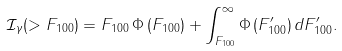<formula> <loc_0><loc_0><loc_500><loc_500>\mathcal { I } _ { \gamma } ( > F _ { 1 0 0 } ) = F _ { 1 0 0 } \, \Phi \, ( F _ { 1 0 0 } ) + \int _ { F _ { 1 0 0 } } ^ { \infty } \Phi \, ( F ^ { \prime } _ { 1 0 0 } ) \, d F ^ { \prime } _ { 1 0 0 } .</formula> 